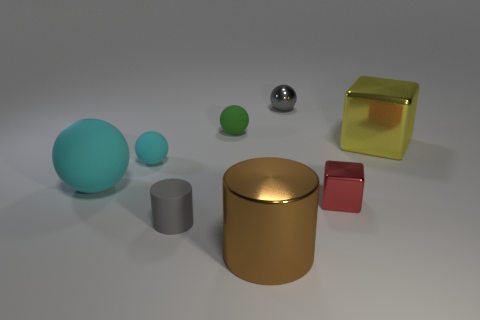What is the color of the big rubber sphere? cyan 